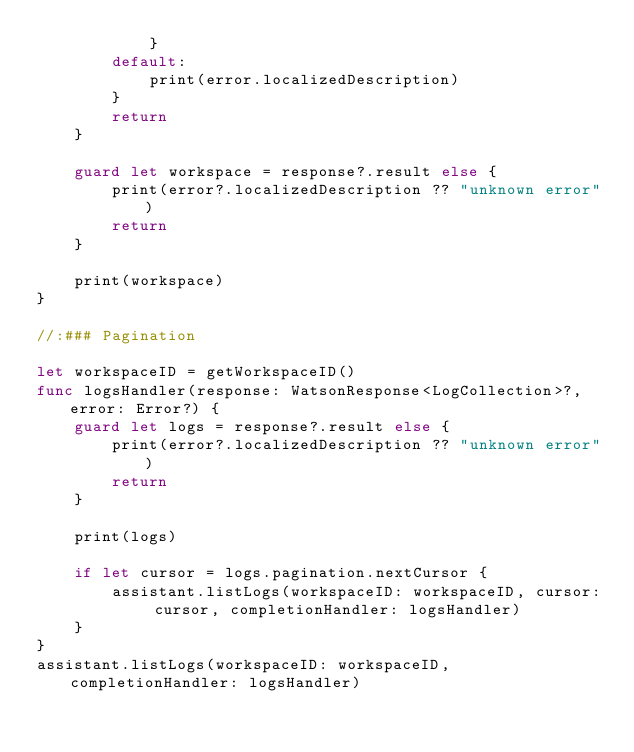Convert code to text. <code><loc_0><loc_0><loc_500><loc_500><_Swift_>            }
        default:
            print(error.localizedDescription)
        }
        return
    }

    guard let workspace = response?.result else {
        print(error?.localizedDescription ?? "unknown error")
        return
    }

    print(workspace)
}

//:### Pagination

let workspaceID = getWorkspaceID()
func logsHandler(response: WatsonResponse<LogCollection>?, error: Error?) {
    guard let logs = response?.result else {
        print(error?.localizedDescription ?? "unknown error")
        return
    }

    print(logs)

    if let cursor = logs.pagination.nextCursor {
        assistant.listLogs(workspaceID: workspaceID, cursor: cursor, completionHandler: logsHandler)
    }
}
assistant.listLogs(workspaceID: workspaceID, completionHandler: logsHandler)
</code> 